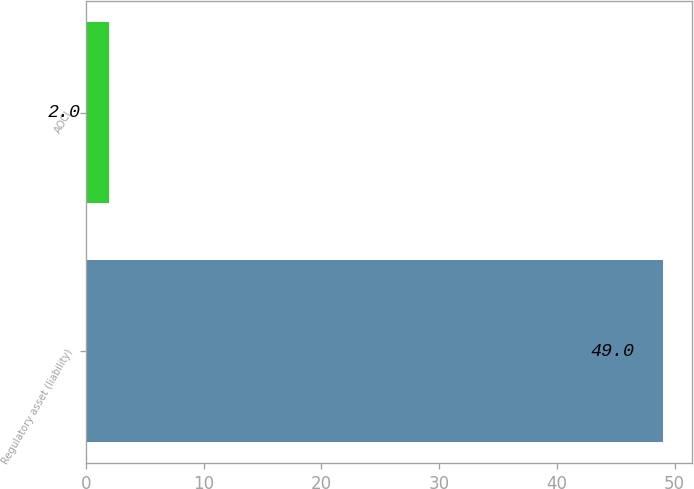Convert chart. <chart><loc_0><loc_0><loc_500><loc_500><bar_chart><fcel>Regulatory asset (liability)<fcel>AOCI<nl><fcel>49<fcel>2<nl></chart> 